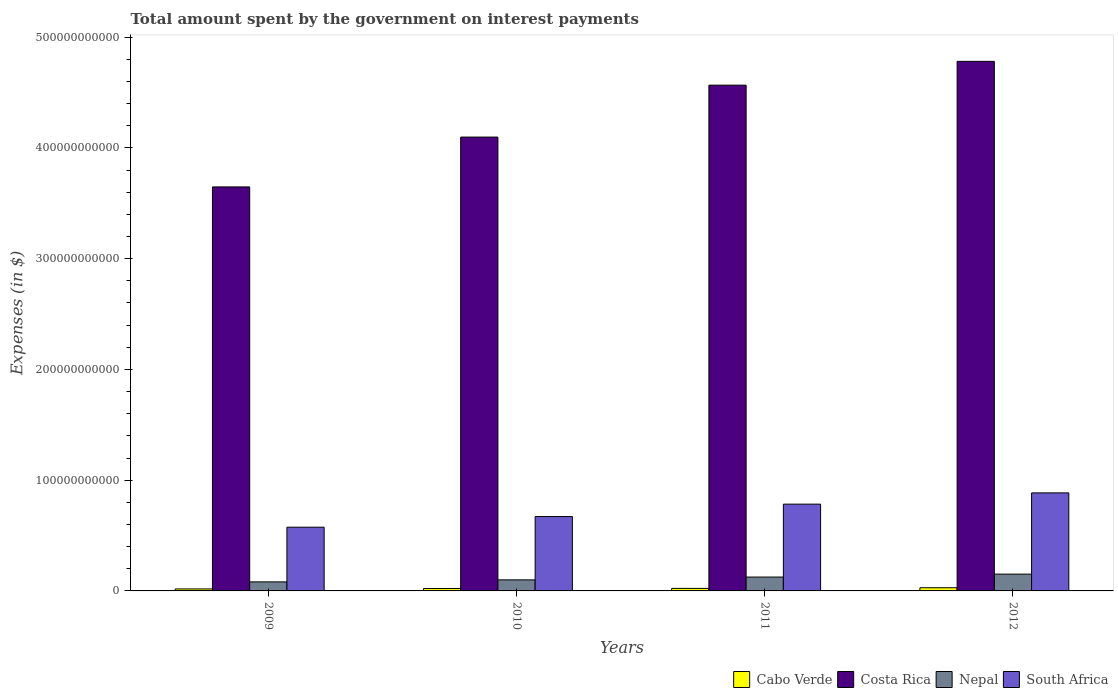How many groups of bars are there?
Your answer should be compact. 4. How many bars are there on the 3rd tick from the left?
Your answer should be compact. 4. How many bars are there on the 1st tick from the right?
Offer a terse response. 4. What is the label of the 2nd group of bars from the left?
Make the answer very short. 2010. In how many cases, is the number of bars for a given year not equal to the number of legend labels?
Keep it short and to the point. 0. What is the amount spent on interest payments by the government in Nepal in 2011?
Keep it short and to the point. 1.25e+1. Across all years, what is the maximum amount spent on interest payments by the government in South Africa?
Your answer should be compact. 8.85e+1. Across all years, what is the minimum amount spent on interest payments by the government in Cabo Verde?
Offer a very short reply. 1.82e+09. What is the total amount spent on interest payments by the government in Costa Rica in the graph?
Make the answer very short. 1.71e+12. What is the difference between the amount spent on interest payments by the government in South Africa in 2010 and that in 2012?
Ensure brevity in your answer.  -2.14e+1. What is the difference between the amount spent on interest payments by the government in Costa Rica in 2011 and the amount spent on interest payments by the government in Cabo Verde in 2010?
Make the answer very short. 4.54e+11. What is the average amount spent on interest payments by the government in Nepal per year?
Your answer should be compact. 1.15e+1. In the year 2011, what is the difference between the amount spent on interest payments by the government in Cabo Verde and amount spent on interest payments by the government in Nepal?
Your answer should be compact. -1.02e+1. In how many years, is the amount spent on interest payments by the government in South Africa greater than 420000000000 $?
Provide a succinct answer. 0. What is the ratio of the amount spent on interest payments by the government in South Africa in 2011 to that in 2012?
Your answer should be very brief. 0.89. Is the amount spent on interest payments by the government in Nepal in 2009 less than that in 2011?
Your response must be concise. Yes. Is the difference between the amount spent on interest payments by the government in Cabo Verde in 2011 and 2012 greater than the difference between the amount spent on interest payments by the government in Nepal in 2011 and 2012?
Offer a very short reply. Yes. What is the difference between the highest and the second highest amount spent on interest payments by the government in South Africa?
Your answer should be compact. 1.02e+1. What is the difference between the highest and the lowest amount spent on interest payments by the government in Costa Rica?
Your answer should be very brief. 1.13e+11. In how many years, is the amount spent on interest payments by the government in Cabo Verde greater than the average amount spent on interest payments by the government in Cabo Verde taken over all years?
Your response must be concise. 1. What does the 1st bar from the left in 2009 represents?
Ensure brevity in your answer.  Cabo Verde. What does the 1st bar from the right in 2009 represents?
Provide a short and direct response. South Africa. Is it the case that in every year, the sum of the amount spent on interest payments by the government in Cabo Verde and amount spent on interest payments by the government in Costa Rica is greater than the amount spent on interest payments by the government in South Africa?
Offer a very short reply. Yes. How many bars are there?
Your response must be concise. 16. Are all the bars in the graph horizontal?
Make the answer very short. No. What is the difference between two consecutive major ticks on the Y-axis?
Offer a terse response. 1.00e+11. Does the graph contain any zero values?
Give a very brief answer. No. Does the graph contain grids?
Provide a succinct answer. No. How many legend labels are there?
Ensure brevity in your answer.  4. How are the legend labels stacked?
Your answer should be compact. Horizontal. What is the title of the graph?
Ensure brevity in your answer.  Total amount spent by the government on interest payments. What is the label or title of the X-axis?
Provide a succinct answer. Years. What is the label or title of the Y-axis?
Your answer should be compact. Expenses (in $). What is the Expenses (in $) of Cabo Verde in 2009?
Make the answer very short. 1.82e+09. What is the Expenses (in $) in Costa Rica in 2009?
Ensure brevity in your answer.  3.65e+11. What is the Expenses (in $) in Nepal in 2009?
Keep it short and to the point. 8.15e+09. What is the Expenses (in $) in South Africa in 2009?
Make the answer very short. 5.75e+1. What is the Expenses (in $) of Cabo Verde in 2010?
Give a very brief answer. 2.16e+09. What is the Expenses (in $) in Costa Rica in 2010?
Your response must be concise. 4.10e+11. What is the Expenses (in $) of Nepal in 2010?
Give a very brief answer. 9.98e+09. What is the Expenses (in $) of South Africa in 2010?
Offer a very short reply. 6.72e+1. What is the Expenses (in $) in Cabo Verde in 2011?
Provide a succinct answer. 2.28e+09. What is the Expenses (in $) of Costa Rica in 2011?
Provide a short and direct response. 4.57e+11. What is the Expenses (in $) in Nepal in 2011?
Offer a very short reply. 1.25e+1. What is the Expenses (in $) in South Africa in 2011?
Your answer should be compact. 7.83e+1. What is the Expenses (in $) in Cabo Verde in 2012?
Ensure brevity in your answer.  2.87e+09. What is the Expenses (in $) of Costa Rica in 2012?
Ensure brevity in your answer.  4.78e+11. What is the Expenses (in $) of Nepal in 2012?
Your answer should be compact. 1.52e+1. What is the Expenses (in $) in South Africa in 2012?
Offer a terse response. 8.85e+1. Across all years, what is the maximum Expenses (in $) in Cabo Verde?
Your answer should be very brief. 2.87e+09. Across all years, what is the maximum Expenses (in $) of Costa Rica?
Your response must be concise. 4.78e+11. Across all years, what is the maximum Expenses (in $) in Nepal?
Your answer should be compact. 1.52e+1. Across all years, what is the maximum Expenses (in $) in South Africa?
Your response must be concise. 8.85e+1. Across all years, what is the minimum Expenses (in $) in Cabo Verde?
Your answer should be very brief. 1.82e+09. Across all years, what is the minimum Expenses (in $) of Costa Rica?
Keep it short and to the point. 3.65e+11. Across all years, what is the minimum Expenses (in $) in Nepal?
Provide a succinct answer. 8.15e+09. Across all years, what is the minimum Expenses (in $) of South Africa?
Provide a short and direct response. 5.75e+1. What is the total Expenses (in $) of Cabo Verde in the graph?
Provide a short and direct response. 9.12e+09. What is the total Expenses (in $) of Costa Rica in the graph?
Your answer should be compact. 1.71e+12. What is the total Expenses (in $) of Nepal in the graph?
Offer a very short reply. 4.58e+1. What is the total Expenses (in $) of South Africa in the graph?
Keep it short and to the point. 2.92e+11. What is the difference between the Expenses (in $) of Cabo Verde in 2009 and that in 2010?
Your response must be concise. -3.41e+08. What is the difference between the Expenses (in $) in Costa Rica in 2009 and that in 2010?
Keep it short and to the point. -4.50e+1. What is the difference between the Expenses (in $) of Nepal in 2009 and that in 2010?
Offer a terse response. -1.83e+09. What is the difference between the Expenses (in $) in South Africa in 2009 and that in 2010?
Keep it short and to the point. -9.62e+09. What is the difference between the Expenses (in $) in Cabo Verde in 2009 and that in 2011?
Offer a very short reply. -4.58e+08. What is the difference between the Expenses (in $) in Costa Rica in 2009 and that in 2011?
Provide a short and direct response. -9.19e+1. What is the difference between the Expenses (in $) of Nepal in 2009 and that in 2011?
Offer a terse response. -4.36e+09. What is the difference between the Expenses (in $) of South Africa in 2009 and that in 2011?
Offer a very short reply. -2.08e+1. What is the difference between the Expenses (in $) in Cabo Verde in 2009 and that in 2012?
Keep it short and to the point. -1.05e+09. What is the difference between the Expenses (in $) of Costa Rica in 2009 and that in 2012?
Offer a very short reply. -1.13e+11. What is the difference between the Expenses (in $) in Nepal in 2009 and that in 2012?
Your answer should be compact. -7.01e+09. What is the difference between the Expenses (in $) of South Africa in 2009 and that in 2012?
Your response must be concise. -3.10e+1. What is the difference between the Expenses (in $) of Cabo Verde in 2010 and that in 2011?
Ensure brevity in your answer.  -1.17e+08. What is the difference between the Expenses (in $) of Costa Rica in 2010 and that in 2011?
Provide a short and direct response. -4.69e+1. What is the difference between the Expenses (in $) of Nepal in 2010 and that in 2011?
Keep it short and to the point. -2.54e+09. What is the difference between the Expenses (in $) in South Africa in 2010 and that in 2011?
Ensure brevity in your answer.  -1.12e+1. What is the difference between the Expenses (in $) of Cabo Verde in 2010 and that in 2012?
Make the answer very short. -7.07e+08. What is the difference between the Expenses (in $) of Costa Rica in 2010 and that in 2012?
Provide a short and direct response. -6.84e+1. What is the difference between the Expenses (in $) of Nepal in 2010 and that in 2012?
Make the answer very short. -5.18e+09. What is the difference between the Expenses (in $) in South Africa in 2010 and that in 2012?
Offer a terse response. -2.14e+1. What is the difference between the Expenses (in $) in Cabo Verde in 2011 and that in 2012?
Keep it short and to the point. -5.90e+08. What is the difference between the Expenses (in $) in Costa Rica in 2011 and that in 2012?
Offer a very short reply. -2.15e+1. What is the difference between the Expenses (in $) in Nepal in 2011 and that in 2012?
Give a very brief answer. -2.64e+09. What is the difference between the Expenses (in $) of South Africa in 2011 and that in 2012?
Give a very brief answer. -1.02e+1. What is the difference between the Expenses (in $) in Cabo Verde in 2009 and the Expenses (in $) in Costa Rica in 2010?
Give a very brief answer. -4.08e+11. What is the difference between the Expenses (in $) in Cabo Verde in 2009 and the Expenses (in $) in Nepal in 2010?
Provide a short and direct response. -8.16e+09. What is the difference between the Expenses (in $) in Cabo Verde in 2009 and the Expenses (in $) in South Africa in 2010?
Your answer should be compact. -6.53e+1. What is the difference between the Expenses (in $) in Costa Rica in 2009 and the Expenses (in $) in Nepal in 2010?
Your answer should be compact. 3.55e+11. What is the difference between the Expenses (in $) of Costa Rica in 2009 and the Expenses (in $) of South Africa in 2010?
Provide a succinct answer. 2.98e+11. What is the difference between the Expenses (in $) in Nepal in 2009 and the Expenses (in $) in South Africa in 2010?
Provide a succinct answer. -5.90e+1. What is the difference between the Expenses (in $) in Cabo Verde in 2009 and the Expenses (in $) in Costa Rica in 2011?
Your answer should be very brief. -4.55e+11. What is the difference between the Expenses (in $) of Cabo Verde in 2009 and the Expenses (in $) of Nepal in 2011?
Your response must be concise. -1.07e+1. What is the difference between the Expenses (in $) in Cabo Verde in 2009 and the Expenses (in $) in South Africa in 2011?
Ensure brevity in your answer.  -7.65e+1. What is the difference between the Expenses (in $) in Costa Rica in 2009 and the Expenses (in $) in Nepal in 2011?
Give a very brief answer. 3.52e+11. What is the difference between the Expenses (in $) in Costa Rica in 2009 and the Expenses (in $) in South Africa in 2011?
Your answer should be compact. 2.86e+11. What is the difference between the Expenses (in $) in Nepal in 2009 and the Expenses (in $) in South Africa in 2011?
Offer a very short reply. -7.02e+1. What is the difference between the Expenses (in $) of Cabo Verde in 2009 and the Expenses (in $) of Costa Rica in 2012?
Give a very brief answer. -4.76e+11. What is the difference between the Expenses (in $) in Cabo Verde in 2009 and the Expenses (in $) in Nepal in 2012?
Provide a succinct answer. -1.33e+1. What is the difference between the Expenses (in $) in Cabo Verde in 2009 and the Expenses (in $) in South Africa in 2012?
Provide a succinct answer. -8.67e+1. What is the difference between the Expenses (in $) of Costa Rica in 2009 and the Expenses (in $) of Nepal in 2012?
Provide a succinct answer. 3.50e+11. What is the difference between the Expenses (in $) in Costa Rica in 2009 and the Expenses (in $) in South Africa in 2012?
Provide a short and direct response. 2.76e+11. What is the difference between the Expenses (in $) in Nepal in 2009 and the Expenses (in $) in South Africa in 2012?
Ensure brevity in your answer.  -8.04e+1. What is the difference between the Expenses (in $) of Cabo Verde in 2010 and the Expenses (in $) of Costa Rica in 2011?
Offer a terse response. -4.54e+11. What is the difference between the Expenses (in $) of Cabo Verde in 2010 and the Expenses (in $) of Nepal in 2011?
Give a very brief answer. -1.04e+1. What is the difference between the Expenses (in $) in Cabo Verde in 2010 and the Expenses (in $) in South Africa in 2011?
Make the answer very short. -7.62e+1. What is the difference between the Expenses (in $) of Costa Rica in 2010 and the Expenses (in $) of Nepal in 2011?
Your answer should be very brief. 3.97e+11. What is the difference between the Expenses (in $) of Costa Rica in 2010 and the Expenses (in $) of South Africa in 2011?
Offer a very short reply. 3.31e+11. What is the difference between the Expenses (in $) of Nepal in 2010 and the Expenses (in $) of South Africa in 2011?
Give a very brief answer. -6.84e+1. What is the difference between the Expenses (in $) of Cabo Verde in 2010 and the Expenses (in $) of Costa Rica in 2012?
Your response must be concise. -4.76e+11. What is the difference between the Expenses (in $) in Cabo Verde in 2010 and the Expenses (in $) in Nepal in 2012?
Your answer should be very brief. -1.30e+1. What is the difference between the Expenses (in $) in Cabo Verde in 2010 and the Expenses (in $) in South Africa in 2012?
Your answer should be very brief. -8.64e+1. What is the difference between the Expenses (in $) in Costa Rica in 2010 and the Expenses (in $) in Nepal in 2012?
Offer a very short reply. 3.95e+11. What is the difference between the Expenses (in $) in Costa Rica in 2010 and the Expenses (in $) in South Africa in 2012?
Offer a terse response. 3.21e+11. What is the difference between the Expenses (in $) of Nepal in 2010 and the Expenses (in $) of South Africa in 2012?
Ensure brevity in your answer.  -7.85e+1. What is the difference between the Expenses (in $) of Cabo Verde in 2011 and the Expenses (in $) of Costa Rica in 2012?
Provide a succinct answer. -4.76e+11. What is the difference between the Expenses (in $) in Cabo Verde in 2011 and the Expenses (in $) in Nepal in 2012?
Offer a terse response. -1.29e+1. What is the difference between the Expenses (in $) of Cabo Verde in 2011 and the Expenses (in $) of South Africa in 2012?
Offer a very short reply. -8.62e+1. What is the difference between the Expenses (in $) in Costa Rica in 2011 and the Expenses (in $) in Nepal in 2012?
Your response must be concise. 4.41e+11. What is the difference between the Expenses (in $) of Costa Rica in 2011 and the Expenses (in $) of South Africa in 2012?
Keep it short and to the point. 3.68e+11. What is the difference between the Expenses (in $) in Nepal in 2011 and the Expenses (in $) in South Africa in 2012?
Make the answer very short. -7.60e+1. What is the average Expenses (in $) in Cabo Verde per year?
Provide a short and direct response. 2.28e+09. What is the average Expenses (in $) in Costa Rica per year?
Ensure brevity in your answer.  4.27e+11. What is the average Expenses (in $) of Nepal per year?
Your answer should be very brief. 1.15e+1. What is the average Expenses (in $) of South Africa per year?
Give a very brief answer. 7.29e+1. In the year 2009, what is the difference between the Expenses (in $) of Cabo Verde and Expenses (in $) of Costa Rica?
Give a very brief answer. -3.63e+11. In the year 2009, what is the difference between the Expenses (in $) of Cabo Verde and Expenses (in $) of Nepal?
Your answer should be very brief. -6.34e+09. In the year 2009, what is the difference between the Expenses (in $) in Cabo Verde and Expenses (in $) in South Africa?
Your answer should be very brief. -5.57e+1. In the year 2009, what is the difference between the Expenses (in $) of Costa Rica and Expenses (in $) of Nepal?
Offer a terse response. 3.57e+11. In the year 2009, what is the difference between the Expenses (in $) of Costa Rica and Expenses (in $) of South Africa?
Make the answer very short. 3.07e+11. In the year 2009, what is the difference between the Expenses (in $) of Nepal and Expenses (in $) of South Africa?
Ensure brevity in your answer.  -4.94e+1. In the year 2010, what is the difference between the Expenses (in $) of Cabo Verde and Expenses (in $) of Costa Rica?
Keep it short and to the point. -4.08e+11. In the year 2010, what is the difference between the Expenses (in $) in Cabo Verde and Expenses (in $) in Nepal?
Offer a very short reply. -7.82e+09. In the year 2010, what is the difference between the Expenses (in $) in Cabo Verde and Expenses (in $) in South Africa?
Your response must be concise. -6.50e+1. In the year 2010, what is the difference between the Expenses (in $) in Costa Rica and Expenses (in $) in Nepal?
Keep it short and to the point. 4.00e+11. In the year 2010, what is the difference between the Expenses (in $) of Costa Rica and Expenses (in $) of South Africa?
Keep it short and to the point. 3.43e+11. In the year 2010, what is the difference between the Expenses (in $) in Nepal and Expenses (in $) in South Africa?
Provide a short and direct response. -5.72e+1. In the year 2011, what is the difference between the Expenses (in $) of Cabo Verde and Expenses (in $) of Costa Rica?
Your response must be concise. -4.54e+11. In the year 2011, what is the difference between the Expenses (in $) of Cabo Verde and Expenses (in $) of Nepal?
Provide a succinct answer. -1.02e+1. In the year 2011, what is the difference between the Expenses (in $) of Cabo Verde and Expenses (in $) of South Africa?
Offer a terse response. -7.61e+1. In the year 2011, what is the difference between the Expenses (in $) of Costa Rica and Expenses (in $) of Nepal?
Give a very brief answer. 4.44e+11. In the year 2011, what is the difference between the Expenses (in $) of Costa Rica and Expenses (in $) of South Africa?
Offer a terse response. 3.78e+11. In the year 2011, what is the difference between the Expenses (in $) of Nepal and Expenses (in $) of South Africa?
Keep it short and to the point. -6.58e+1. In the year 2012, what is the difference between the Expenses (in $) of Cabo Verde and Expenses (in $) of Costa Rica?
Offer a very short reply. -4.75e+11. In the year 2012, what is the difference between the Expenses (in $) of Cabo Verde and Expenses (in $) of Nepal?
Give a very brief answer. -1.23e+1. In the year 2012, what is the difference between the Expenses (in $) in Cabo Verde and Expenses (in $) in South Africa?
Provide a short and direct response. -8.57e+1. In the year 2012, what is the difference between the Expenses (in $) in Costa Rica and Expenses (in $) in Nepal?
Offer a terse response. 4.63e+11. In the year 2012, what is the difference between the Expenses (in $) of Costa Rica and Expenses (in $) of South Africa?
Your answer should be very brief. 3.90e+11. In the year 2012, what is the difference between the Expenses (in $) in Nepal and Expenses (in $) in South Africa?
Your response must be concise. -7.34e+1. What is the ratio of the Expenses (in $) in Cabo Verde in 2009 to that in 2010?
Provide a succinct answer. 0.84. What is the ratio of the Expenses (in $) in Costa Rica in 2009 to that in 2010?
Provide a succinct answer. 0.89. What is the ratio of the Expenses (in $) of Nepal in 2009 to that in 2010?
Give a very brief answer. 0.82. What is the ratio of the Expenses (in $) in South Africa in 2009 to that in 2010?
Offer a very short reply. 0.86. What is the ratio of the Expenses (in $) of Cabo Verde in 2009 to that in 2011?
Make the answer very short. 0.8. What is the ratio of the Expenses (in $) of Costa Rica in 2009 to that in 2011?
Give a very brief answer. 0.8. What is the ratio of the Expenses (in $) in Nepal in 2009 to that in 2011?
Offer a very short reply. 0.65. What is the ratio of the Expenses (in $) of South Africa in 2009 to that in 2011?
Give a very brief answer. 0.73. What is the ratio of the Expenses (in $) of Cabo Verde in 2009 to that in 2012?
Provide a succinct answer. 0.63. What is the ratio of the Expenses (in $) of Costa Rica in 2009 to that in 2012?
Provide a short and direct response. 0.76. What is the ratio of the Expenses (in $) in Nepal in 2009 to that in 2012?
Your response must be concise. 0.54. What is the ratio of the Expenses (in $) in South Africa in 2009 to that in 2012?
Your response must be concise. 0.65. What is the ratio of the Expenses (in $) in Cabo Verde in 2010 to that in 2011?
Provide a succinct answer. 0.95. What is the ratio of the Expenses (in $) of Costa Rica in 2010 to that in 2011?
Keep it short and to the point. 0.9. What is the ratio of the Expenses (in $) of Nepal in 2010 to that in 2011?
Keep it short and to the point. 0.8. What is the ratio of the Expenses (in $) in Cabo Verde in 2010 to that in 2012?
Offer a terse response. 0.75. What is the ratio of the Expenses (in $) in Costa Rica in 2010 to that in 2012?
Offer a very short reply. 0.86. What is the ratio of the Expenses (in $) of Nepal in 2010 to that in 2012?
Give a very brief answer. 0.66. What is the ratio of the Expenses (in $) in South Africa in 2010 to that in 2012?
Provide a short and direct response. 0.76. What is the ratio of the Expenses (in $) of Cabo Verde in 2011 to that in 2012?
Offer a very short reply. 0.79. What is the ratio of the Expenses (in $) in Costa Rica in 2011 to that in 2012?
Your answer should be very brief. 0.95. What is the ratio of the Expenses (in $) in Nepal in 2011 to that in 2012?
Provide a succinct answer. 0.83. What is the ratio of the Expenses (in $) of South Africa in 2011 to that in 2012?
Offer a very short reply. 0.89. What is the difference between the highest and the second highest Expenses (in $) of Cabo Verde?
Offer a terse response. 5.90e+08. What is the difference between the highest and the second highest Expenses (in $) of Costa Rica?
Your answer should be compact. 2.15e+1. What is the difference between the highest and the second highest Expenses (in $) in Nepal?
Your answer should be very brief. 2.64e+09. What is the difference between the highest and the second highest Expenses (in $) in South Africa?
Ensure brevity in your answer.  1.02e+1. What is the difference between the highest and the lowest Expenses (in $) in Cabo Verde?
Your answer should be very brief. 1.05e+09. What is the difference between the highest and the lowest Expenses (in $) of Costa Rica?
Provide a succinct answer. 1.13e+11. What is the difference between the highest and the lowest Expenses (in $) in Nepal?
Provide a short and direct response. 7.01e+09. What is the difference between the highest and the lowest Expenses (in $) of South Africa?
Offer a terse response. 3.10e+1. 